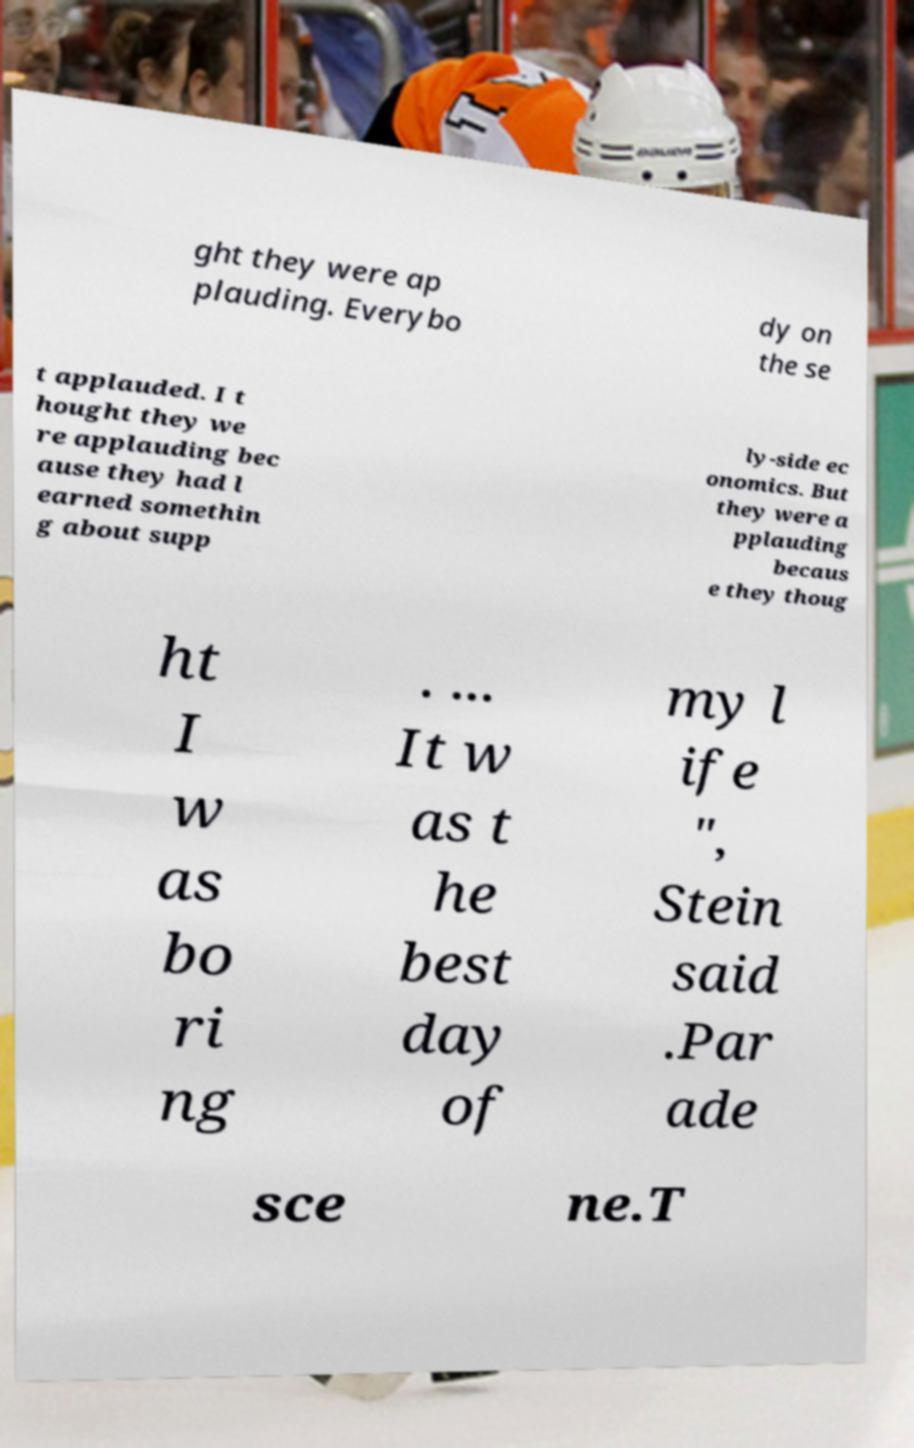There's text embedded in this image that I need extracted. Can you transcribe it verbatim? ght they were ap plauding. Everybo dy on the se t applauded. I t hought they we re applauding bec ause they had l earned somethin g about supp ly-side ec onomics. But they were a pplauding becaus e they thoug ht I w as bo ri ng . ... It w as t he best day of my l ife ", Stein said .Par ade sce ne.T 